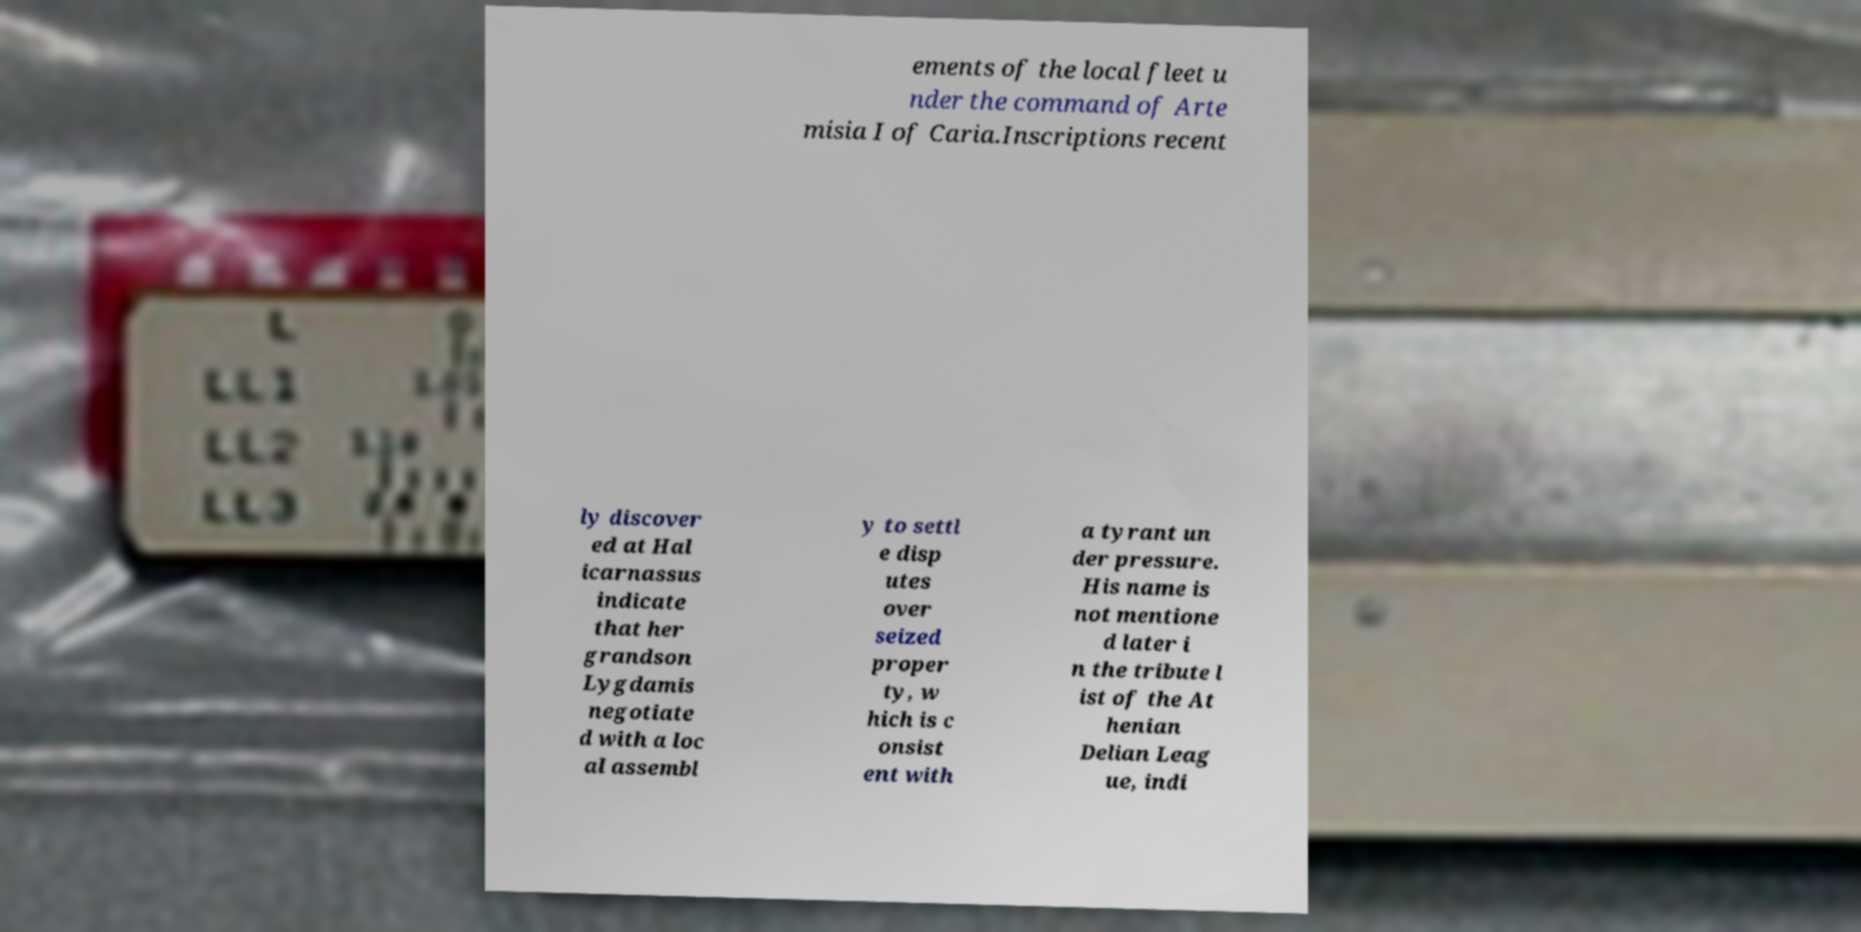Could you assist in decoding the text presented in this image and type it out clearly? ements of the local fleet u nder the command of Arte misia I of Caria.Inscriptions recent ly discover ed at Hal icarnassus indicate that her grandson Lygdamis negotiate d with a loc al assembl y to settl e disp utes over seized proper ty, w hich is c onsist ent with a tyrant un der pressure. His name is not mentione d later i n the tribute l ist of the At henian Delian Leag ue, indi 